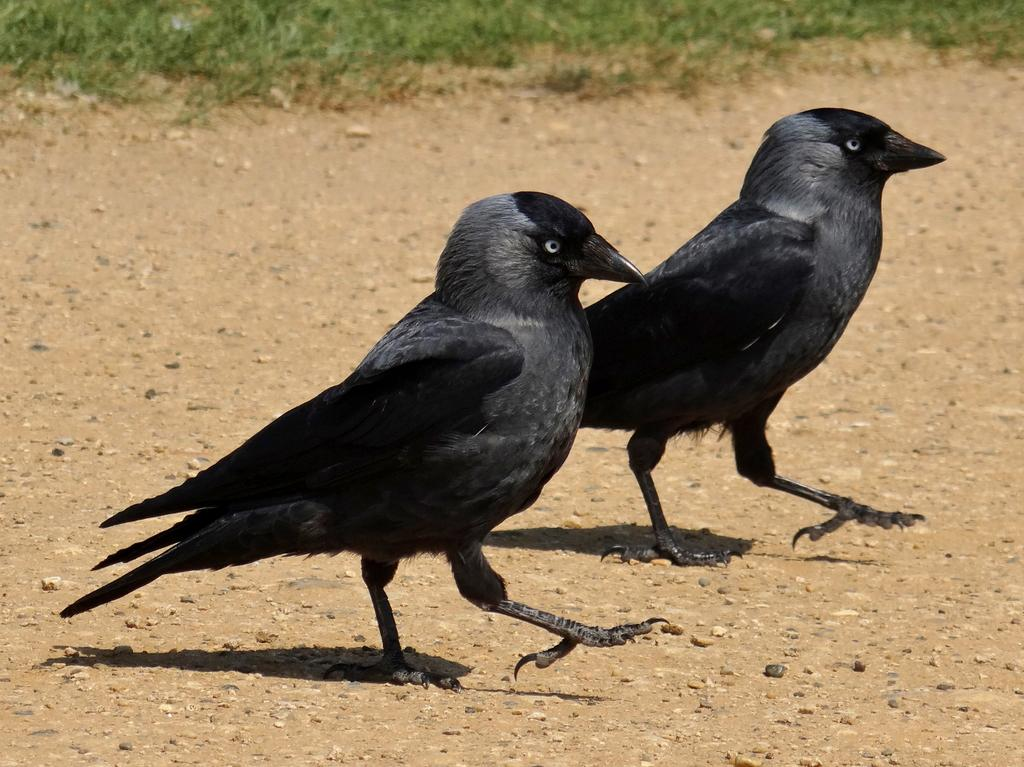What type of animals are in the image? There are two black crows in the image. Where are the crows located in the image? The crows are standing on a path. What can be seen on the path in the image? There are tiny stones visible on the path. What is visible in the background of the image? There is grass in the background of the image. What are the crows' parents doing in the image? There is no information about the crows' parents in the image, as it only shows the two crows standing on a path. 